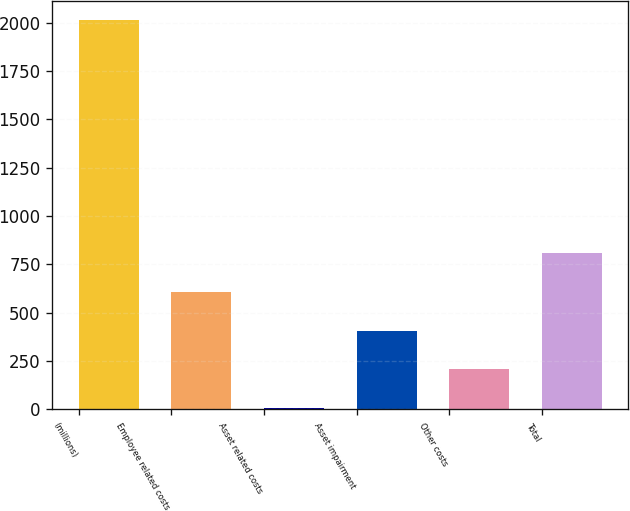<chart> <loc_0><loc_0><loc_500><loc_500><bar_chart><fcel>(millions)<fcel>Employee related costs<fcel>Asset related costs<fcel>Asset impairment<fcel>Other costs<fcel>Total<nl><fcel>2013<fcel>608.1<fcel>6<fcel>407.4<fcel>206.7<fcel>808.8<nl></chart> 